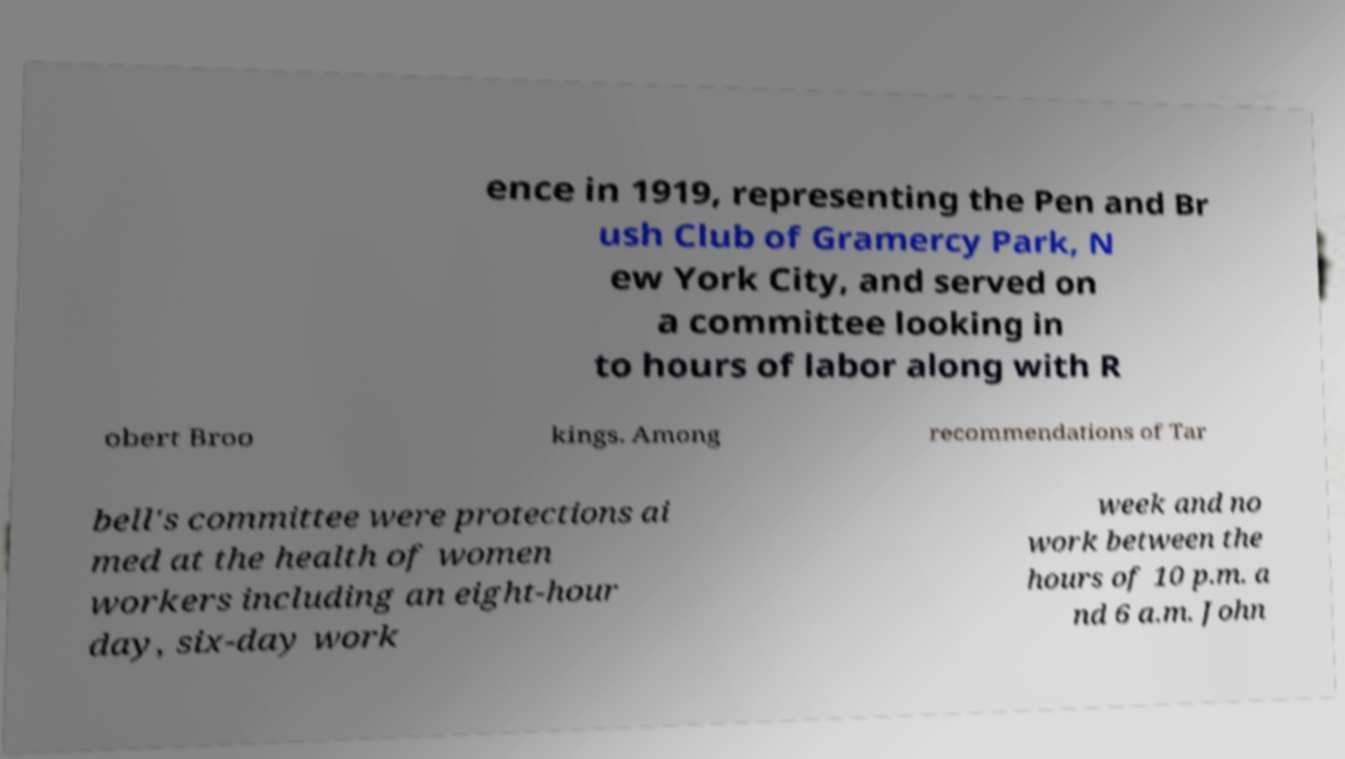For documentation purposes, I need the text within this image transcribed. Could you provide that? ence in 1919, representing the Pen and Br ush Club of Gramercy Park, N ew York City, and served on a committee looking in to hours of labor along with R obert Broo kings. Among recommendations of Tar bell's committee were protections ai med at the health of women workers including an eight-hour day, six-day work week and no work between the hours of 10 p.m. a nd 6 a.m. John 